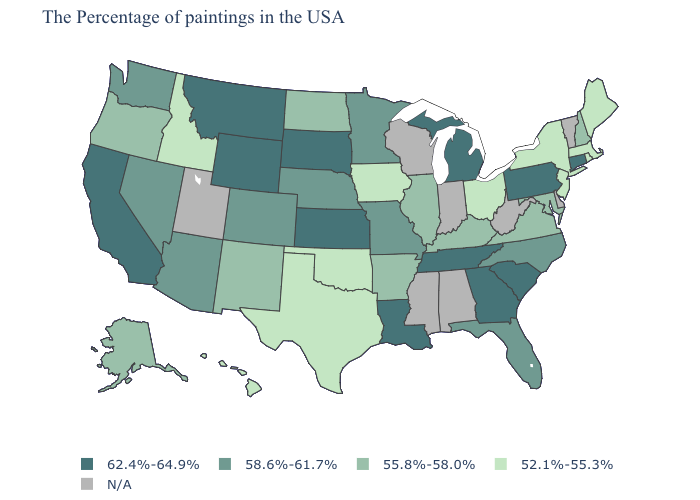Which states have the lowest value in the Northeast?
Short answer required. Maine, Massachusetts, Rhode Island, New York, New Jersey. What is the value of Delaware?
Answer briefly. N/A. Name the states that have a value in the range 52.1%-55.3%?
Give a very brief answer. Maine, Massachusetts, Rhode Island, New York, New Jersey, Ohio, Iowa, Oklahoma, Texas, Idaho, Hawaii. Name the states that have a value in the range 55.8%-58.0%?
Answer briefly. New Hampshire, Maryland, Virginia, Kentucky, Illinois, Arkansas, North Dakota, New Mexico, Oregon, Alaska. Which states hav the highest value in the MidWest?
Answer briefly. Michigan, Kansas, South Dakota. Does the map have missing data?
Keep it brief. Yes. Among the states that border Maryland , which have the highest value?
Answer briefly. Pennsylvania. Name the states that have a value in the range 62.4%-64.9%?
Be succinct. Connecticut, Pennsylvania, South Carolina, Georgia, Michigan, Tennessee, Louisiana, Kansas, South Dakota, Wyoming, Montana, California. What is the value of North Carolina?
Keep it brief. 58.6%-61.7%. What is the lowest value in states that border New Jersey?
Quick response, please. 52.1%-55.3%. What is the value of Illinois?
Write a very short answer. 55.8%-58.0%. What is the highest value in the USA?
Quick response, please. 62.4%-64.9%. Does Louisiana have the highest value in the South?
Write a very short answer. Yes. What is the lowest value in states that border Louisiana?
Concise answer only. 52.1%-55.3%. 